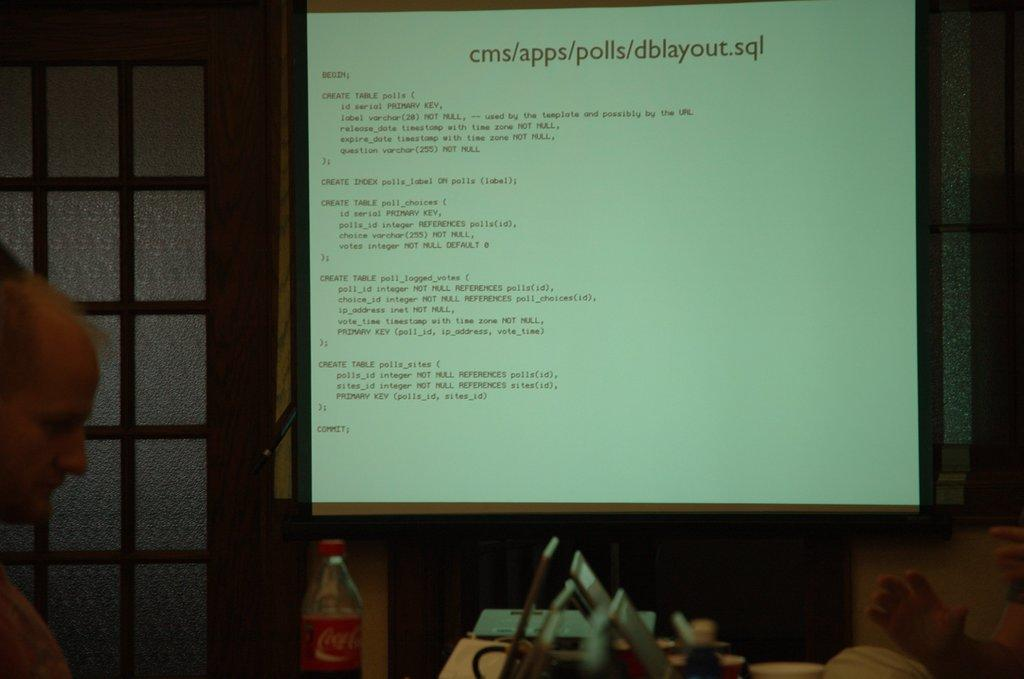<image>
Create a compact narrative representing the image presented. A picture with cms/apps/polls/dblayout.sql wrote on it from a projector 